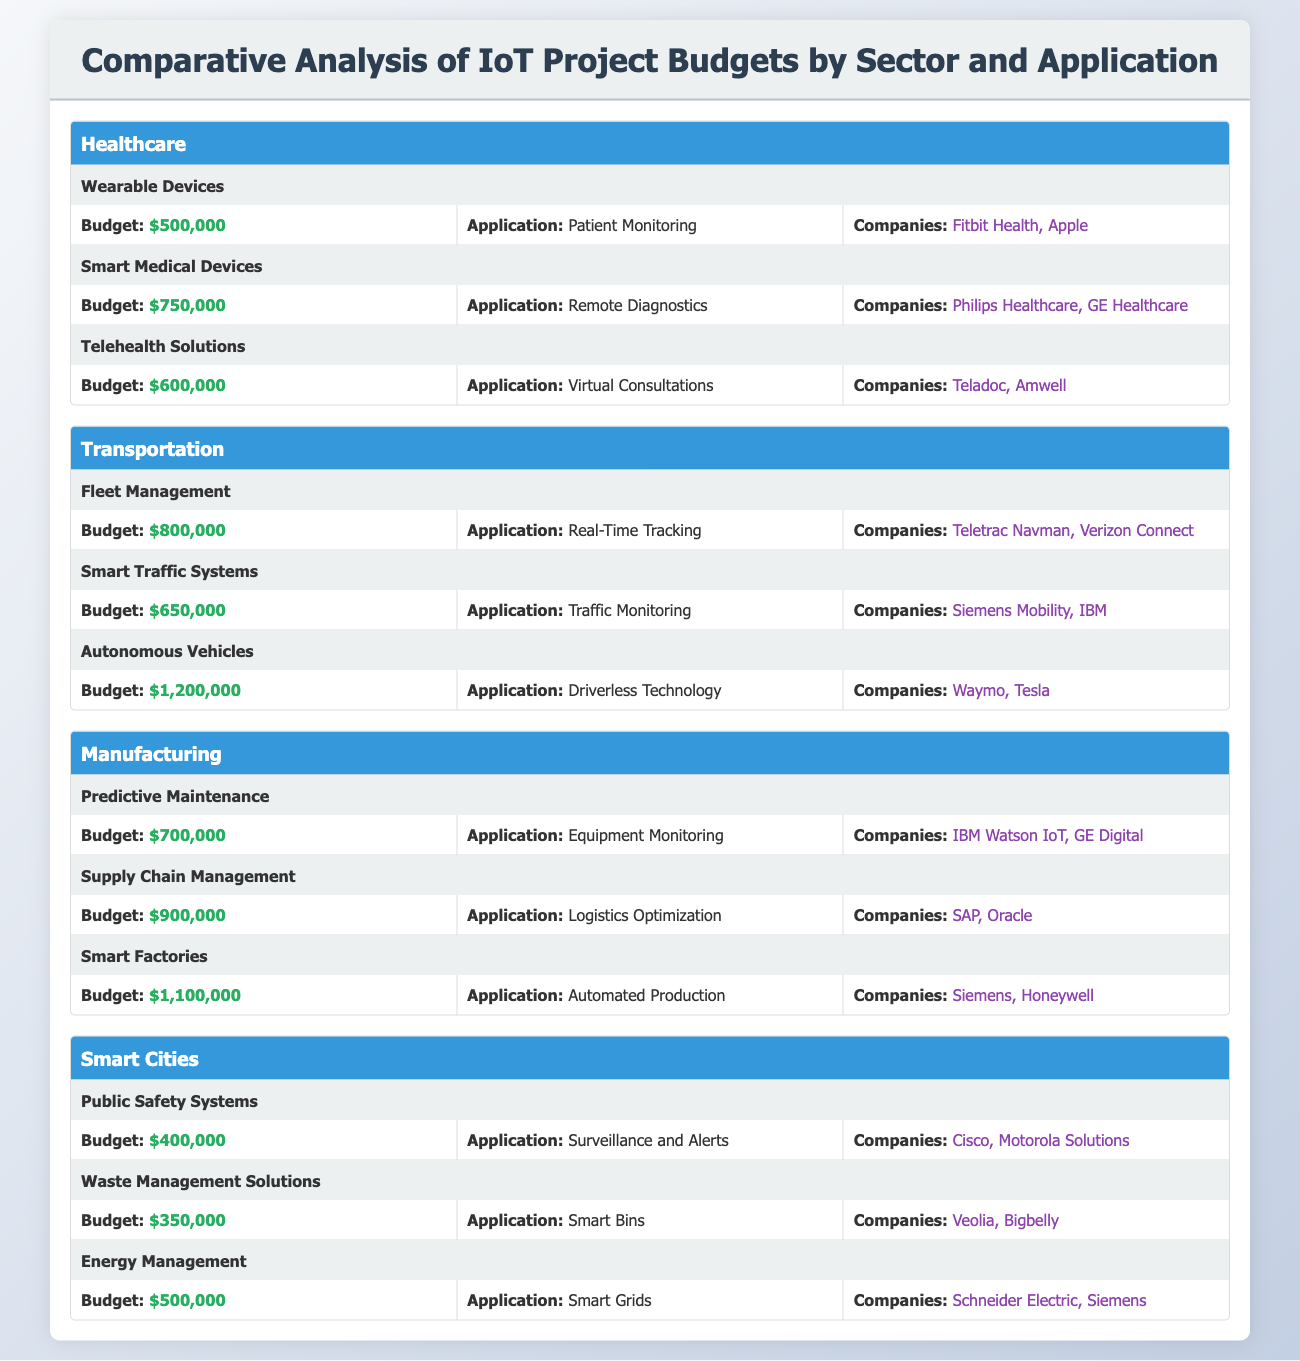What is the budget for Telehealth Solutions in Healthcare? The table shows that the budget for Telehealth Solutions in the Healthcare sector is listed as $600,000.
Answer: $600,000 Which sector has the highest budget allocation? By comparing the budgets of all sectors, the Transportation sector, with the Autonomous Vehicles project at $1,200,000, has the highest budget allocation.
Answer: Transportation What is the total budget for projects in the Smart Cities sector? The budgets for Smart Cities projects are: Public Safety Systems ($400,000), Waste Management Solutions ($350,000), and Energy Management ($500,000). Adding these amounts gives a total of $400,000 + $350,000 + $500,000 = $1,250,000.
Answer: $1,250,000 Is the budget for Smart Medical Devices greater than the budget for Predictive Maintenance? The budget for Smart Medical Devices is $750,000, and the budget for Predictive Maintenance is $700,000. Since $750,000 is greater than $700,000, the statement is true.
Answer: Yes What application corresponds to the highest budget in the Manufacturing sector? In the Manufacturing sector, the Smart Factories project has the highest budget of $1,100,000, and its application is Automated Production.
Answer: Automated Production What is the average budget across all identified IoT projects? To find the average, first sum the budgets: $500,000 + $750,000 + $600,000 + $800,000 + $650,000 + $1,200,000 + $700,000 + $900,000 + $1,100,000 + $400,000 + $350,000 + $500,000 = $8,100,000. There are 12 projects, so the average is $8,100,000 / 12 = $675,000.
Answer: $675,000 Which company is involved in the Supply Chain Management project? The table indicates that the companies involved in the Supply Chain Management project in the Manufacturing sector are SAP and Oracle.
Answer: SAP, Oracle Is there a project in the Smart Cities sector that has a budget less than $400,000? The budgets for the projects in Smart Cities are: Public Safety Systems ($400,000), Waste Management Solutions ($350,000), and Energy Management ($500,000). Since Waste Management Solutions has a budget of $350,000, which is less than $400,000, the statement is true.
Answer: Yes How much more budget is allocated to Smart Factories compared to Fleet Management? The budget for Smart Factories is $1,100,000, and for Fleet Management, it is $800,000. The difference is $1,100,000 - $800,000 = $300,000.
Answer: $300,000 